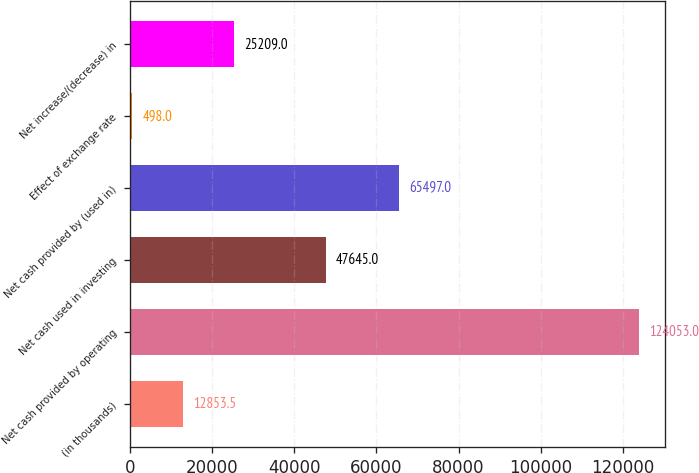<chart> <loc_0><loc_0><loc_500><loc_500><bar_chart><fcel>(in thousands)<fcel>Net cash provided by operating<fcel>Net cash used in investing<fcel>Net cash provided by (used in)<fcel>Effect of exchange rate<fcel>Net increase/(decrease) in<nl><fcel>12853.5<fcel>124053<fcel>47645<fcel>65497<fcel>498<fcel>25209<nl></chart> 